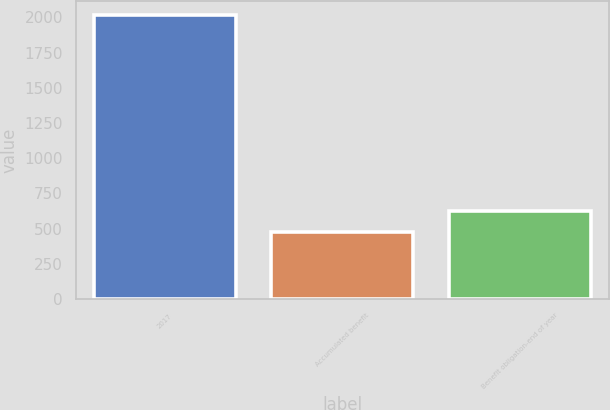Convert chart to OTSL. <chart><loc_0><loc_0><loc_500><loc_500><bar_chart><fcel>2017<fcel>Accumulated benefit<fcel>Benefit obligation-end of year<nl><fcel>2016<fcel>474<fcel>628.2<nl></chart> 